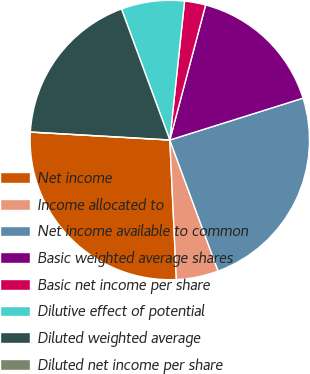Convert chart. <chart><loc_0><loc_0><loc_500><loc_500><pie_chart><fcel>Net income<fcel>Income allocated to<fcel>Net income available to common<fcel>Basic weighted average shares<fcel>Basic net income per share<fcel>Dilutive effect of potential<fcel>Diluted weighted average<fcel>Diluted net income per share<nl><fcel>26.66%<fcel>4.87%<fcel>24.23%<fcel>16.03%<fcel>2.44%<fcel>7.31%<fcel>18.47%<fcel>0.0%<nl></chart> 